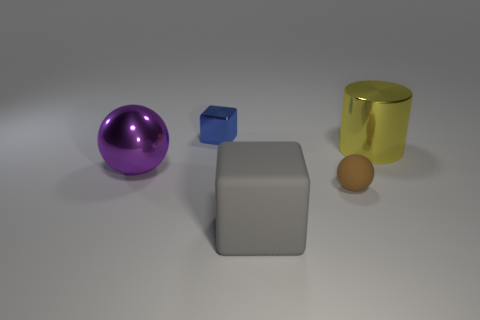Are there any gray cubes of the same size as the gray rubber object? no 